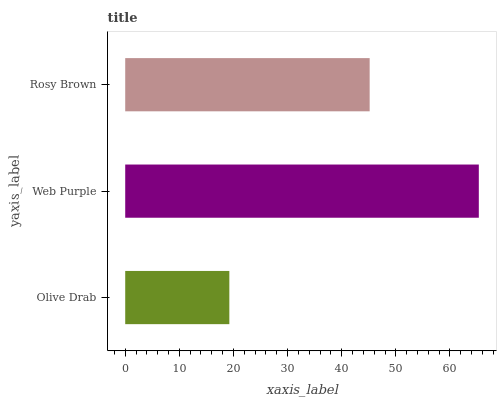Is Olive Drab the minimum?
Answer yes or no. Yes. Is Web Purple the maximum?
Answer yes or no. Yes. Is Rosy Brown the minimum?
Answer yes or no. No. Is Rosy Brown the maximum?
Answer yes or no. No. Is Web Purple greater than Rosy Brown?
Answer yes or no. Yes. Is Rosy Brown less than Web Purple?
Answer yes or no. Yes. Is Rosy Brown greater than Web Purple?
Answer yes or no. No. Is Web Purple less than Rosy Brown?
Answer yes or no. No. Is Rosy Brown the high median?
Answer yes or no. Yes. Is Rosy Brown the low median?
Answer yes or no. Yes. Is Olive Drab the high median?
Answer yes or no. No. Is Web Purple the low median?
Answer yes or no. No. 